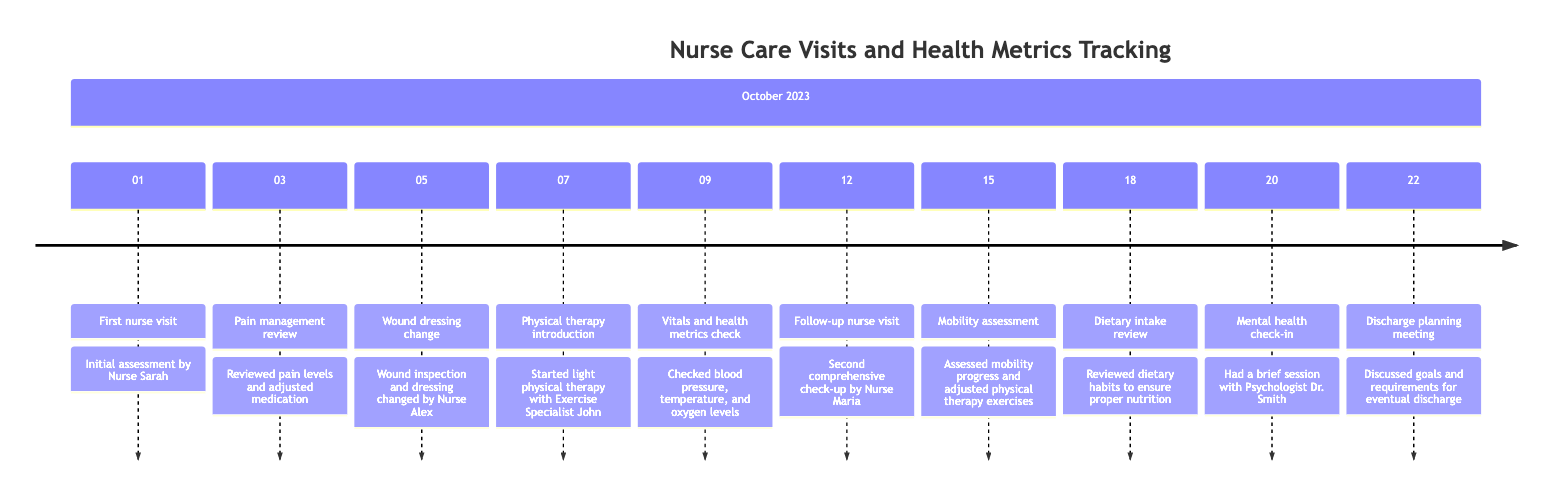What is the date of the first nurse visit? The first nurse visit is indicated at the beginning of the timeline, specifically labeled with the date "2023-10-01".
Answer: 2023-10-01 How many total nurse visits are there in October 2023? By counting the activities labeled as nurse visits in the timeline, there are four distinct nurse visits.
Answer: 4 What activity occurs on October 15? The entry for that date specifically states "Mobility assessment", which shows that on this date the focus was on assessing mobility progress.
Answer: Mobility assessment What was checked on October 9? The activity listed for this date indicates a check of "blood pressure, temperature, and oxygen levels", making it clear these health metrics were examined.
Answer: Vitals and health metrics check Which nurse performed the first assessment? The diagram notes that the initial assessment was conducted by "Nurse Sarah" on the first nurse visit date.
Answer: Nurse Sarah What was the purpose of the meeting on October 22? The timeline indicates that this meeting was for "Discharge planning", showing a discussion on goals and requirements prior to discharge from care.
Answer: Discharge planning meeting On which date was the wound dressing changed? The timeline lists the activity of a wound dressing change specifically on the date "2023-10-05", confirming this particular action.
Answer: 2023-10-05 Who conducted the pain management review? The timeline specifies that the pain management review was done by no one other than the nurse, although it doesn't specify their name, it indicates a general nurse activity.
Answer: Nurse What activity indicates the start of physical therapy? The timeline states that physical therapy was introduced on "2023-10-07", marking it as the relevant activity for the start of therapy.
Answer: Physical therapy introduction 